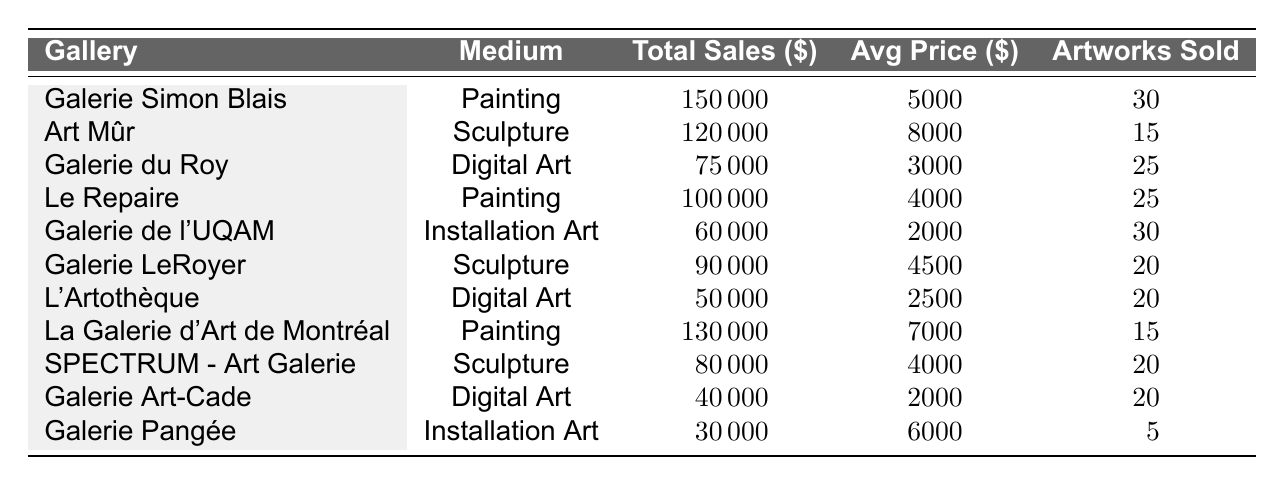What is the total sales for "Galerie Simon Blais"? The total sales for "Galerie Simon Blais" is directly provided in the table under the "Total Sales" column, which shows \$150,000.
Answer: 150000 Which medium sold the highest number of artworks? The medium with the highest number of artworks sold is "Painting," with a total of 75 artworks sold (30 + 25 + 15).
Answer: Painting What is the average price of artworks sold at "Galerie du Roy"? "Galerie du Roy" has an average price listed in the table, which is \$3,000.
Answer: 3000 Did "L'Artothèque" sell more artworks than "Galerie LeRoyer"? "L'Artothèque" sold 20 artworks, while "Galerie LeRoyer" sold 20 artworks. Since the numbers are equal, the answer is no.
Answer: No What is the total sales from all the galleries that sell Sculpture? The total sales for Sculpture can be calculated by adding the sales from "Art Mûr" (\$120,000), "Galerie LeRoyer" (\$90,000), and "SPECTRUM - Art Galerie" (\$80,000), which equals \$390,000.
Answer: 390000 Which gallery had the lowest total sales? By examining the "Total Sales" column, "Galerie Pangée" shows the lowest total sales at \$30,000.
Answer: Galerie Pangée What is the difference in total sales between "La Galerie d'Art de Montréal" and "Galerie du Roy"? The total sales for "La Galerie d'Art de Montréal" is \$130,000, and for "Galerie du Roy" it is \$75,000. The difference is \$130,000 - \$75,000 = \$55,000.
Answer: 55000 Is the average price of Digital Art sold higher than that of Installation Art? The average price for Digital Art is \$2,500 (from "L'Artothèque" and "Galerie Art-Cade") and for Installation Art is \$4,000 (from "Galerie de l'UQAM" and "Galerie Pangée"). Since \$2,500 is lower than \$4,000, the answer is no.
Answer: No Which medium had the least total sales across all galleries? The total sales for Installation Art is \$60,000 (from "Galerie de l'UQAM" and "Galerie Pangée"), whereas Digital Art has \$125,000 (from two galleries) and Sculpture has \$290,000 (from three galleries). So, Installation Art is the least.
Answer: Installation Art What is the average sales performance of Painting across the three galleries? The total sales for Painting is \$150,000 (from "Galerie Simon Blais") + \$100,000 (from "Le Repaire") + \$130,000 (from "La Galerie d'Art de Montréal") = \$380,000. The number of artworks sold is 30 + 25 + 15 = 70. The average sales performance would be \$380,000 / 70 = \$5,428.57.
Answer: 5428.57 